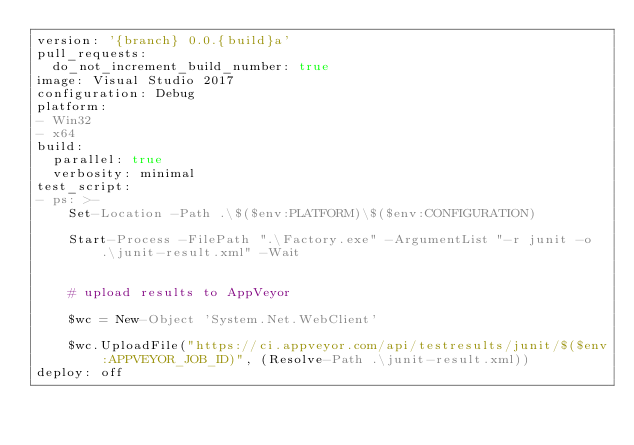Convert code to text. <code><loc_0><loc_0><loc_500><loc_500><_YAML_>version: '{branch} 0.0.{build}a'
pull_requests:
  do_not_increment_build_number: true
image: Visual Studio 2017
configuration: Debug
platform:
- Win32
- x64
build:
  parallel: true
  verbosity: minimal
test_script:
- ps: >-
    Set-Location -Path .\$($env:PLATFORM)\$($env:CONFIGURATION)

    Start-Process -FilePath ".\Factory.exe" -ArgumentList "-r junit -o .\junit-result.xml" -Wait


    # upload results to AppVeyor

    $wc = New-Object 'System.Net.WebClient'

    $wc.UploadFile("https://ci.appveyor.com/api/testresults/junit/$($env:APPVEYOR_JOB_ID)", (Resolve-Path .\junit-result.xml))
deploy: off</code> 